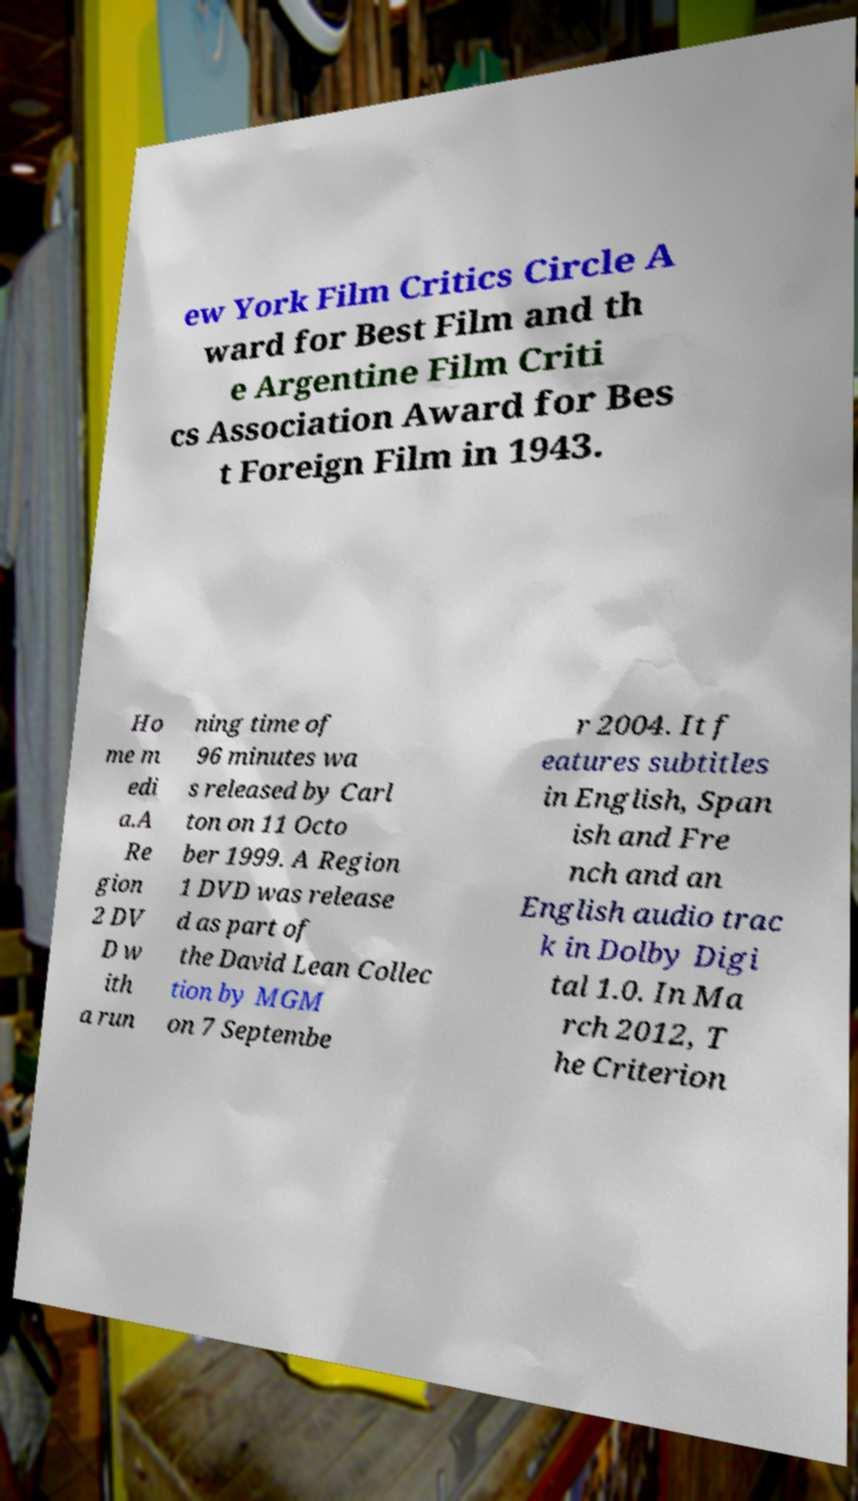Could you assist in decoding the text presented in this image and type it out clearly? ew York Film Critics Circle A ward for Best Film and th e Argentine Film Criti cs Association Award for Bes t Foreign Film in 1943. Ho me m edi a.A Re gion 2 DV D w ith a run ning time of 96 minutes wa s released by Carl ton on 11 Octo ber 1999. A Region 1 DVD was release d as part of the David Lean Collec tion by MGM on 7 Septembe r 2004. It f eatures subtitles in English, Span ish and Fre nch and an English audio trac k in Dolby Digi tal 1.0. In Ma rch 2012, T he Criterion 